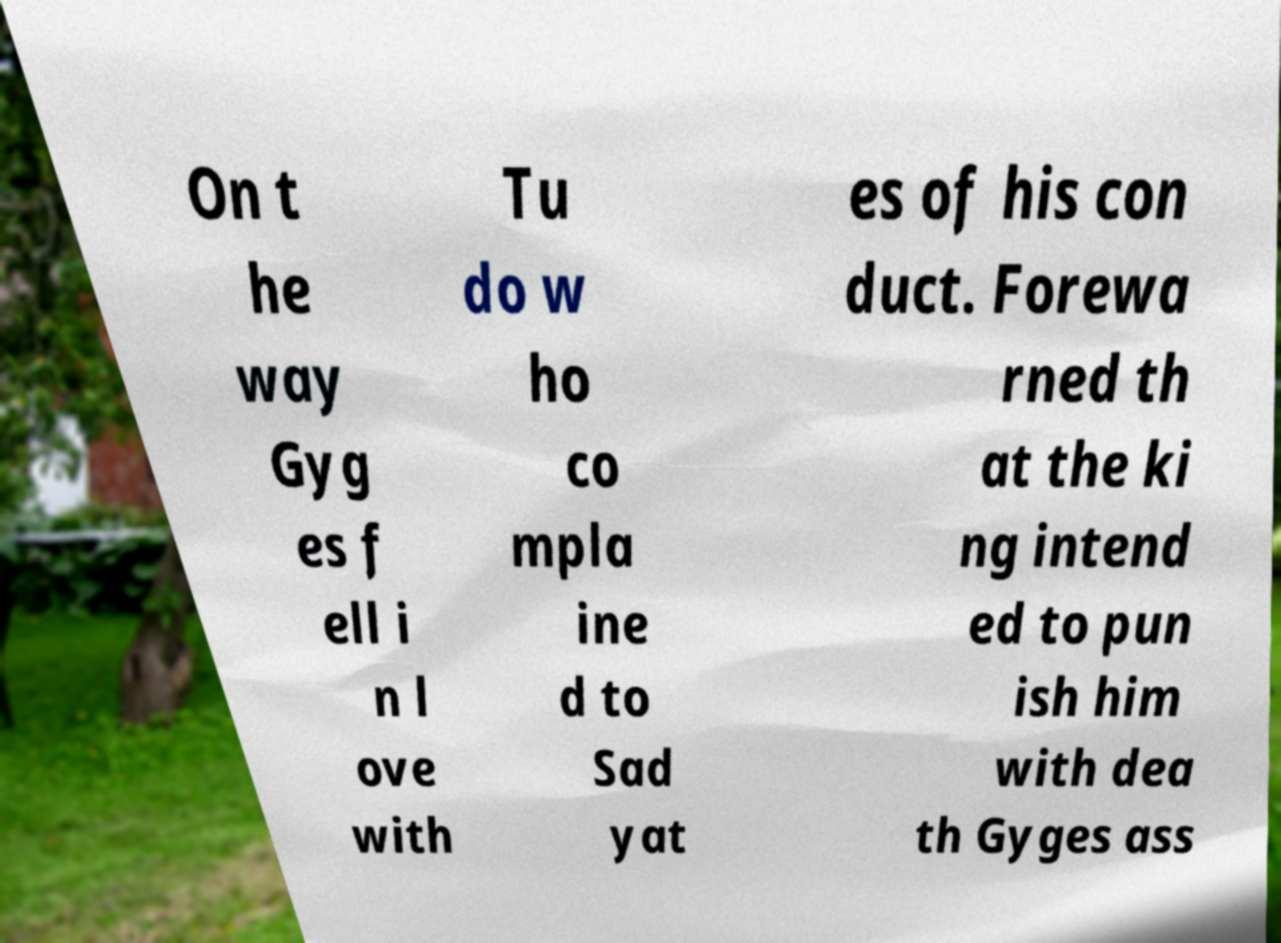There's text embedded in this image that I need extracted. Can you transcribe it verbatim? On t he way Gyg es f ell i n l ove with Tu do w ho co mpla ine d to Sad yat es of his con duct. Forewa rned th at the ki ng intend ed to pun ish him with dea th Gyges ass 